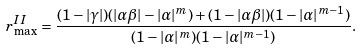Convert formula to latex. <formula><loc_0><loc_0><loc_500><loc_500>r _ { \max } ^ { I I } = \frac { ( 1 - | \gamma | ) ( | \alpha \beta | - | \alpha | ^ { m } ) + ( 1 - | \alpha \beta | ) ( 1 - | \alpha | ^ { m - 1 } ) } { ( 1 - | \alpha | ^ { m } ) ( 1 - | \alpha | ^ { m - 1 } ) } .</formula> 